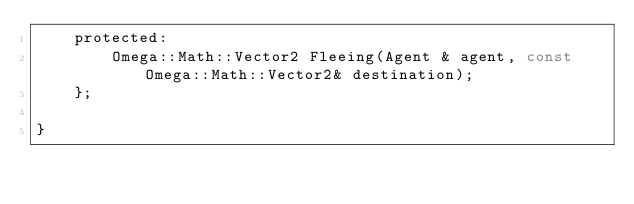Convert code to text. <code><loc_0><loc_0><loc_500><loc_500><_C_>	protected:
		Omega::Math::Vector2 Fleeing(Agent & agent, const Omega::Math::Vector2& destination);
	};

}
</code> 